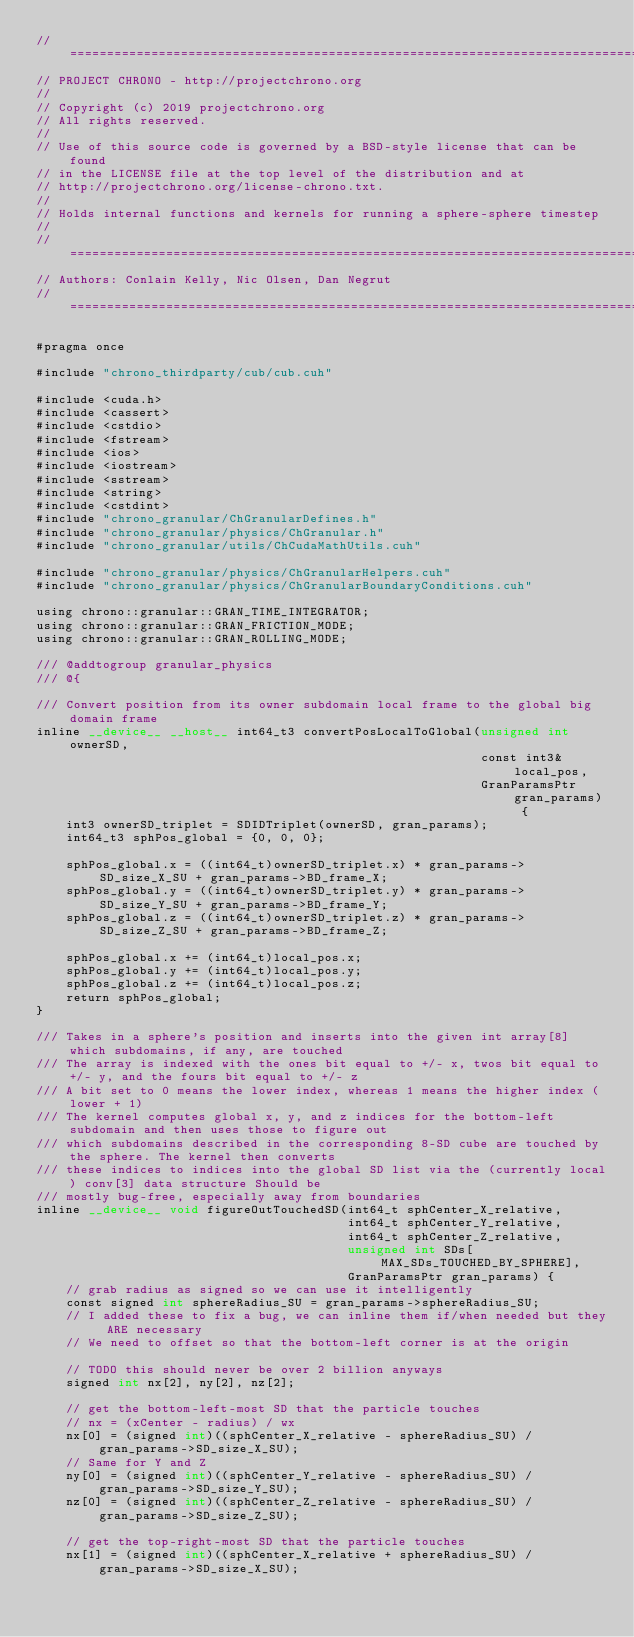<code> <loc_0><loc_0><loc_500><loc_500><_Cuda_>// =============================================================================
// PROJECT CHRONO - http://projectchrono.org
//
// Copyright (c) 2019 projectchrono.org
// All rights reserved.
//
// Use of this source code is governed by a BSD-style license that can be found
// in the LICENSE file at the top level of the distribution and at
// http://projectchrono.org/license-chrono.txt.
//
// Holds internal functions and kernels for running a sphere-sphere timestep
//
// =============================================================================
// Authors: Conlain Kelly, Nic Olsen, Dan Negrut
// =============================================================================

#pragma once

#include "chrono_thirdparty/cub/cub.cuh"

#include <cuda.h>
#include <cassert>
#include <cstdio>
#include <fstream>
#include <ios>
#include <iostream>
#include <sstream>
#include <string>
#include <cstdint>
#include "chrono_granular/ChGranularDefines.h"
#include "chrono_granular/physics/ChGranular.h"
#include "chrono_granular/utils/ChCudaMathUtils.cuh"

#include "chrono_granular/physics/ChGranularHelpers.cuh"
#include "chrono_granular/physics/ChGranularBoundaryConditions.cuh"

using chrono::granular::GRAN_TIME_INTEGRATOR;
using chrono::granular::GRAN_FRICTION_MODE;
using chrono::granular::GRAN_ROLLING_MODE;

/// @addtogroup granular_physics
/// @{

/// Convert position from its owner subdomain local frame to the global big domain frame
inline __device__ __host__ int64_t3 convertPosLocalToGlobal(unsigned int ownerSD,
                                                            const int3& local_pos,
                                                            GranParamsPtr gran_params) {
    int3 ownerSD_triplet = SDIDTriplet(ownerSD, gran_params);
    int64_t3 sphPos_global = {0, 0, 0};

    sphPos_global.x = ((int64_t)ownerSD_triplet.x) * gran_params->SD_size_X_SU + gran_params->BD_frame_X;
    sphPos_global.y = ((int64_t)ownerSD_triplet.y) * gran_params->SD_size_Y_SU + gran_params->BD_frame_Y;
    sphPos_global.z = ((int64_t)ownerSD_triplet.z) * gran_params->SD_size_Z_SU + gran_params->BD_frame_Z;

    sphPos_global.x += (int64_t)local_pos.x;
    sphPos_global.y += (int64_t)local_pos.y;
    sphPos_global.z += (int64_t)local_pos.z;
    return sphPos_global;
}

/// Takes in a sphere's position and inserts into the given int array[8] which subdomains, if any, are touched
/// The array is indexed with the ones bit equal to +/- x, twos bit equal to +/- y, and the fours bit equal to +/- z
/// A bit set to 0 means the lower index, whereas 1 means the higher index (lower + 1)
/// The kernel computes global x, y, and z indices for the bottom-left subdomain and then uses those to figure out
/// which subdomains described in the corresponding 8-SD cube are touched by the sphere. The kernel then converts
/// these indices to indices into the global SD list via the (currently local) conv[3] data structure Should be
/// mostly bug-free, especially away from boundaries
inline __device__ void figureOutTouchedSD(int64_t sphCenter_X_relative,
                                          int64_t sphCenter_Y_relative,
                                          int64_t sphCenter_Z_relative,
                                          unsigned int SDs[MAX_SDs_TOUCHED_BY_SPHERE],
                                          GranParamsPtr gran_params) {
    // grab radius as signed so we can use it intelligently
    const signed int sphereRadius_SU = gran_params->sphereRadius_SU;
    // I added these to fix a bug, we can inline them if/when needed but they ARE necessary
    // We need to offset so that the bottom-left corner is at the origin

    // TODO this should never be over 2 billion anyways
    signed int nx[2], ny[2], nz[2];

    // get the bottom-left-most SD that the particle touches
    // nx = (xCenter - radius) / wx
    nx[0] = (signed int)((sphCenter_X_relative - sphereRadius_SU) / gran_params->SD_size_X_SU);
    // Same for Y and Z
    ny[0] = (signed int)((sphCenter_Y_relative - sphereRadius_SU) / gran_params->SD_size_Y_SU);
    nz[0] = (signed int)((sphCenter_Z_relative - sphereRadius_SU) / gran_params->SD_size_Z_SU);

    // get the top-right-most SD that the particle touches
    nx[1] = (signed int)((sphCenter_X_relative + sphereRadius_SU) / gran_params->SD_size_X_SU);</code> 